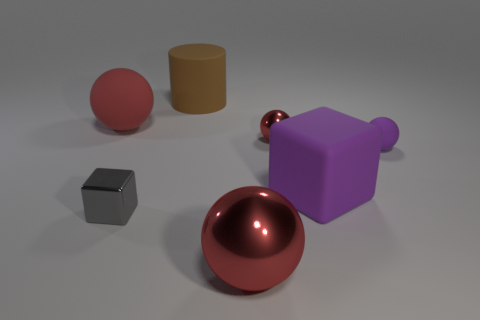There is a metal sphere to the left of the small red metallic thing; is its size the same as the rubber sphere that is on the left side of the big cube?
Offer a terse response. Yes. There is a big red sphere behind the small shiny thing that is behind the purple block; what is it made of?
Offer a very short reply. Rubber. Are there fewer purple cubes that are behind the big shiny sphere than metal things that are right of the red matte sphere?
Ensure brevity in your answer.  Yes. There is a tiny ball that is the same color as the big matte ball; what material is it?
Keep it short and to the point. Metal. Is there anything else that is the same shape as the brown rubber object?
Make the answer very short. No. What is the material of the large red ball right of the red rubber object?
Your answer should be very brief. Metal. Is there any other thing that has the same size as the brown object?
Keep it short and to the point. Yes. Are there any small metal things on the left side of the tiny red object?
Make the answer very short. Yes. What is the shape of the brown matte object?
Keep it short and to the point. Cylinder. What number of things are red spheres behind the large purple object or blue things?
Your response must be concise. 2. 